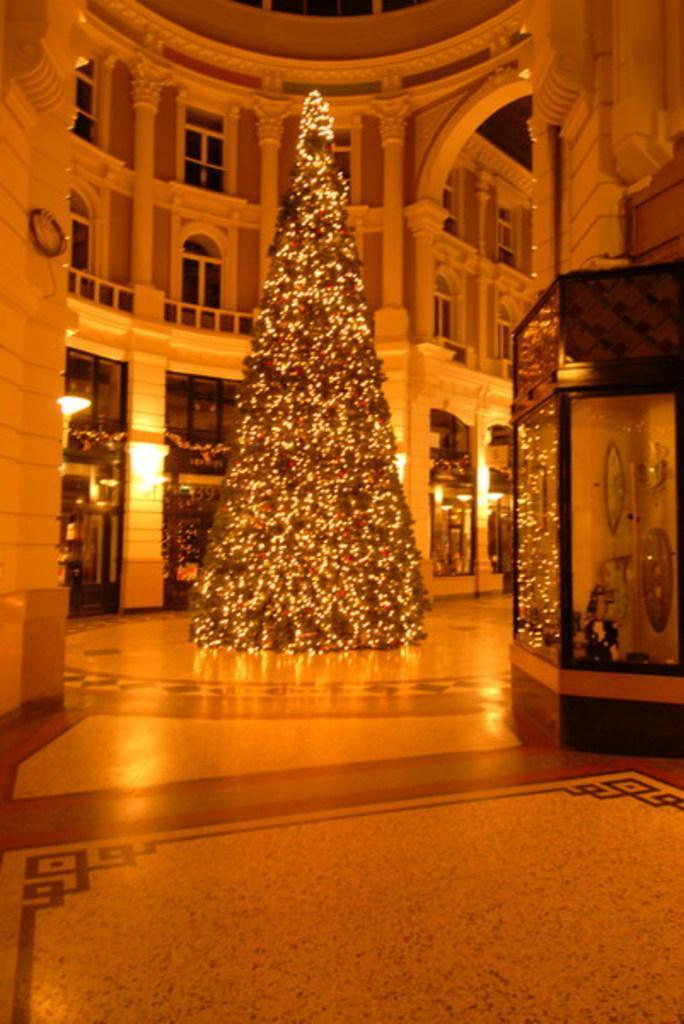Could you give a brief overview of what you see in this image? In this image, we can see a Christmas tree inside the building decorated with some lights. There is a display chamber on the right side of the image. 